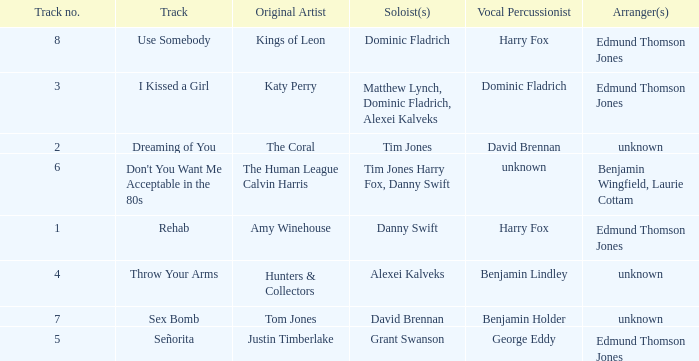Who is the percussionist for The Coral? David Brennan. 